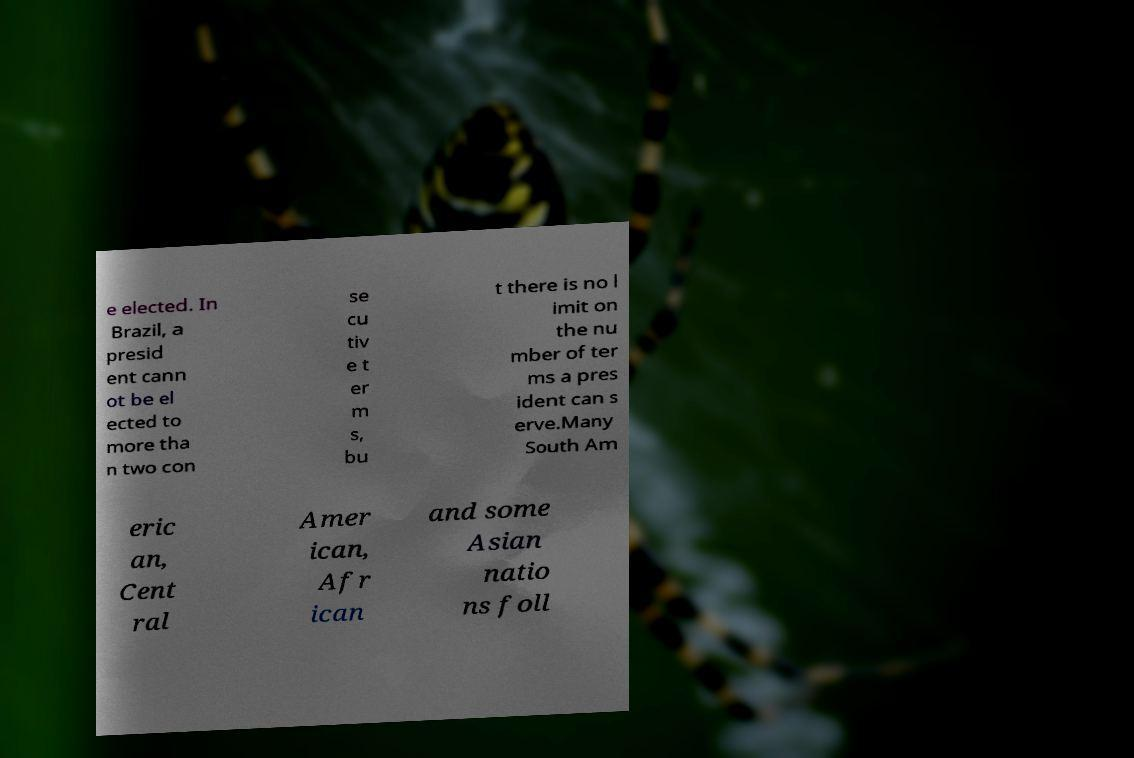Could you extract and type out the text from this image? e elected. In Brazil, a presid ent cann ot be el ected to more tha n two con se cu tiv e t er m s, bu t there is no l imit on the nu mber of ter ms a pres ident can s erve.Many South Am eric an, Cent ral Amer ican, Afr ican and some Asian natio ns foll 